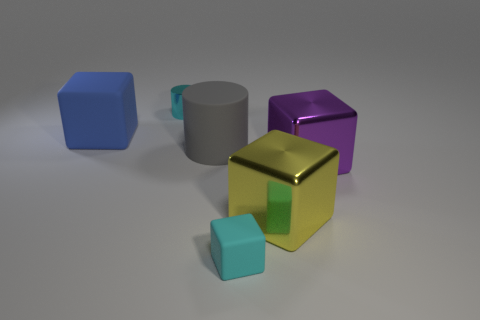Subtract 1 cubes. How many cubes are left? 3 Add 4 yellow matte balls. How many objects exist? 10 Subtract all cubes. How many objects are left? 2 Subtract 0 brown cubes. How many objects are left? 6 Subtract all yellow shiny cubes. Subtract all blue rubber objects. How many objects are left? 4 Add 3 small matte blocks. How many small matte blocks are left? 4 Add 5 green rubber things. How many green rubber things exist? 5 